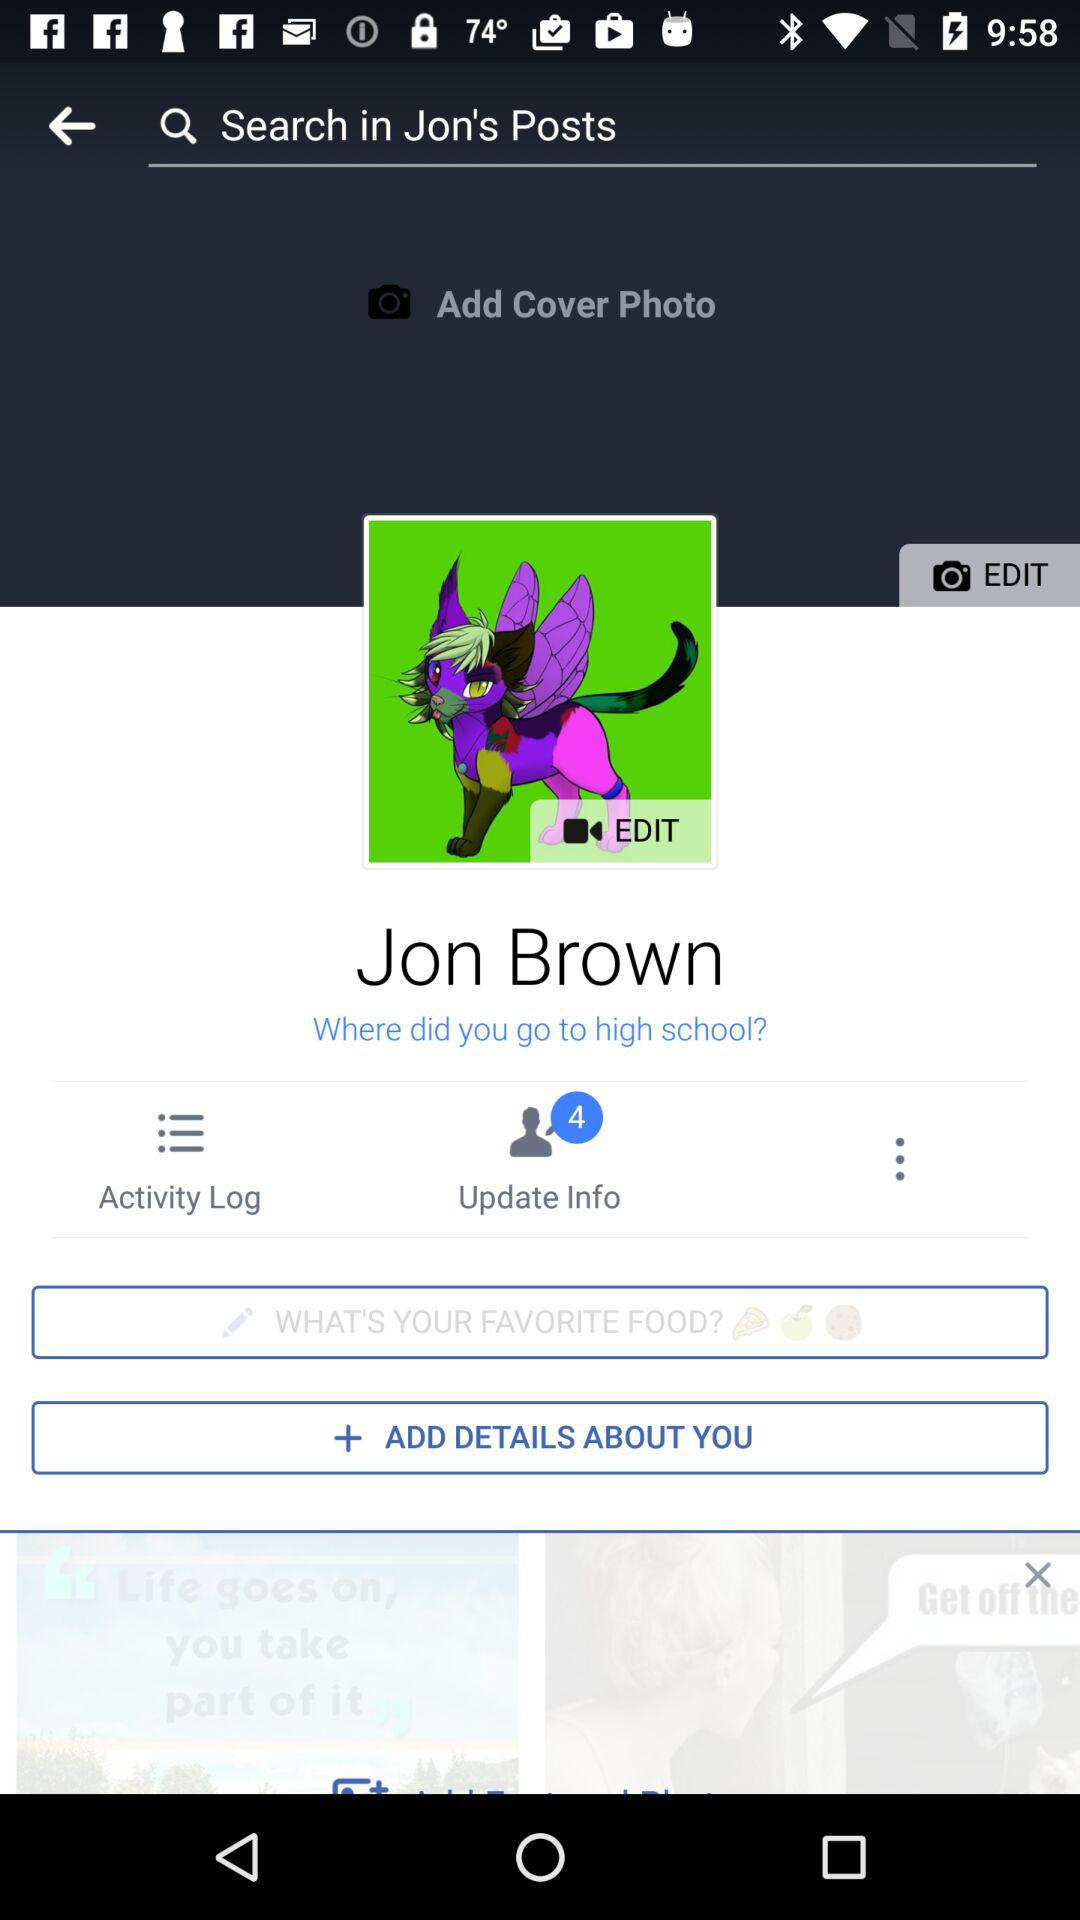How many notifications are there for "Update Info"? There are 4 notifications for "Update Info". 